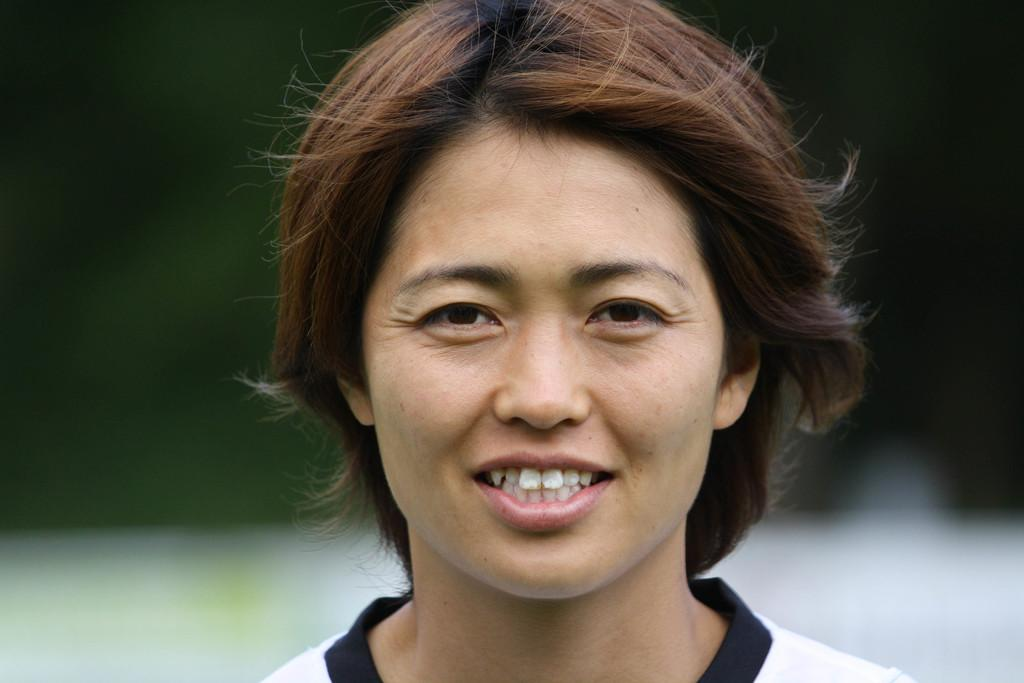Who or what is the main subject in the image? There is a person in the image. What is the person wearing? The person is wearing a white shirt. Are there any accessories visible on the person? Yes, the person has a black choker. What colors can be seen in the background of the image? The background of the image is green and white in color. Is the person holding a hot object in the image? There is no indication in the image that the person is holding a hot object. Can you see any fire in the image? No, there is no fire present in the image. 